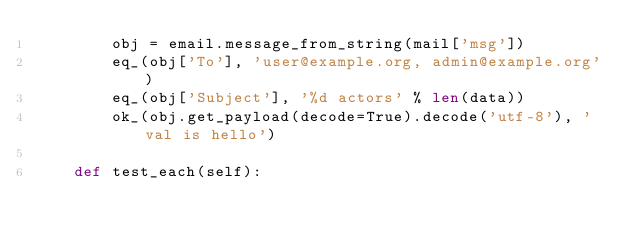<code> <loc_0><loc_0><loc_500><loc_500><_Python_>        obj = email.message_from_string(mail['msg'])
        eq_(obj['To'], 'user@example.org, admin@example.org')
        eq_(obj['Subject'], '%d actors' % len(data))
        ok_(obj.get_payload(decode=True).decode('utf-8'), 'val is hello')

    def test_each(self):</code> 